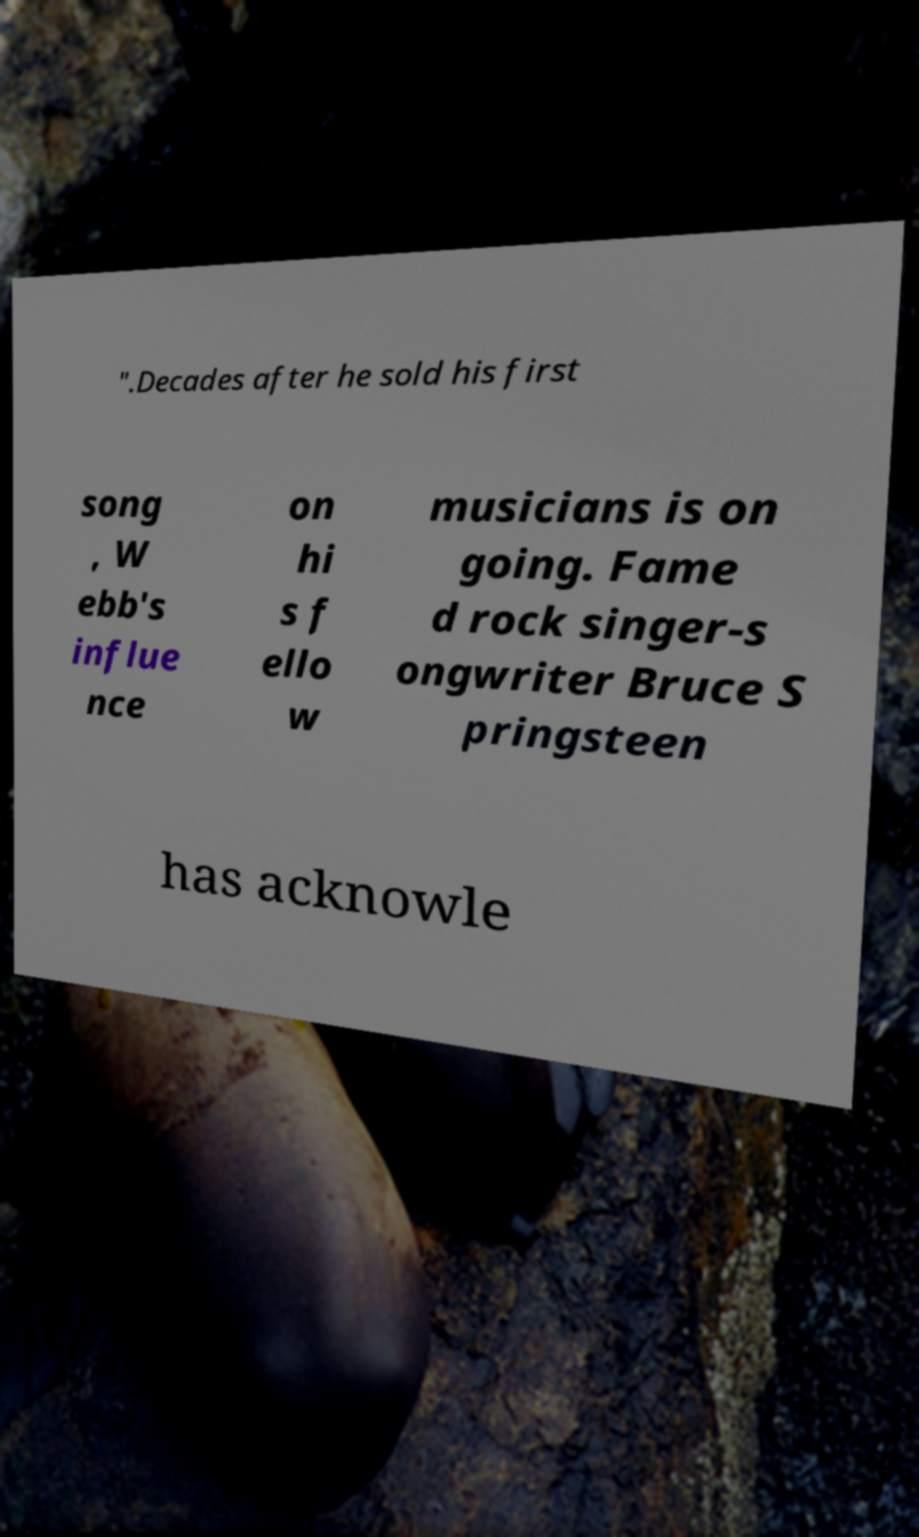Can you read and provide the text displayed in the image?This photo seems to have some interesting text. Can you extract and type it out for me? ".Decades after he sold his first song , W ebb's influe nce on hi s f ello w musicians is on going. Fame d rock singer-s ongwriter Bruce S pringsteen has acknowle 